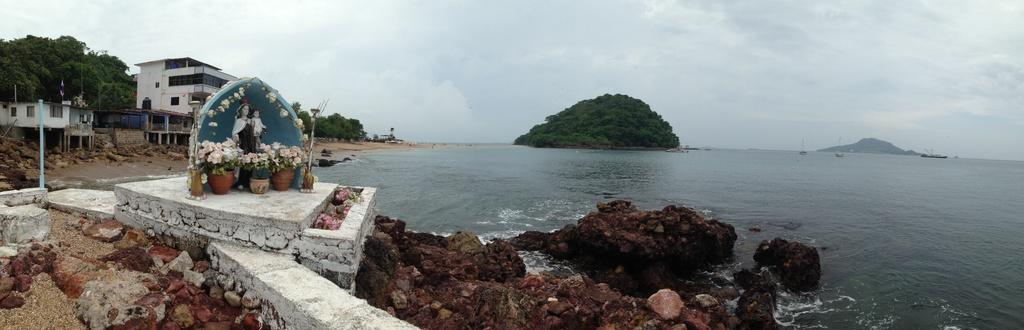What is one of the main elements in the image? There is water in the image. What other objects or features can be seen in the image? There are rocks, statues, plants, flowers, poles, trees, buildings, boats, and a mountain in the image. What can be seen in the background of the image? The sky is visible in the background of the image, with clouds present. What is the size of the cough in the image? There is no cough present in the image, so it is not possible to determine its size. 